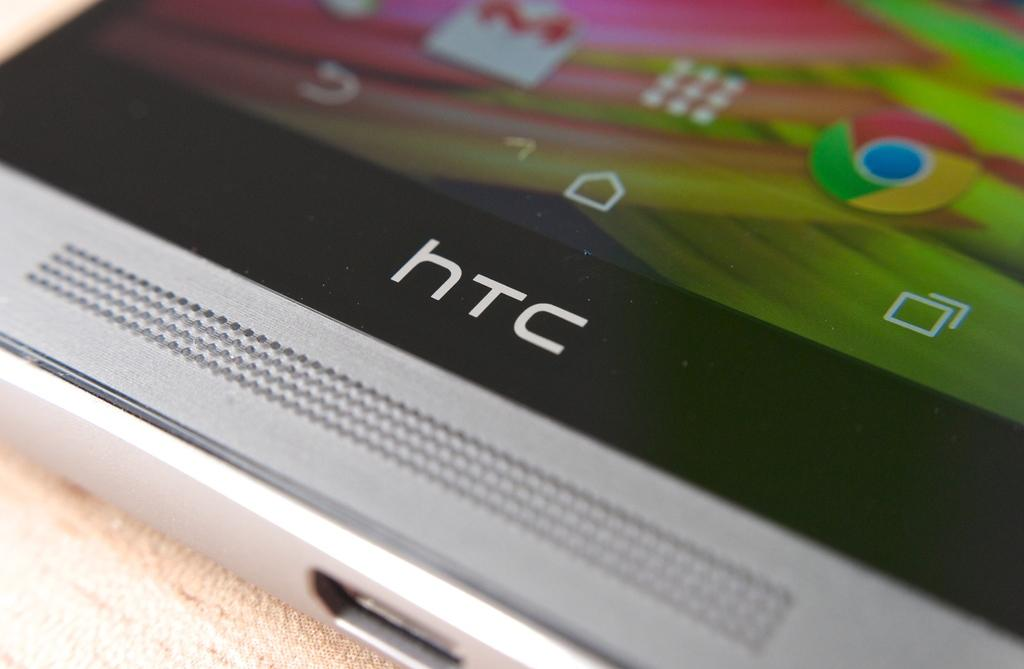Provide a one-sentence caption for the provided image. An HTC phone is displayed with Google Chrome and Gmail apps on the screen. 